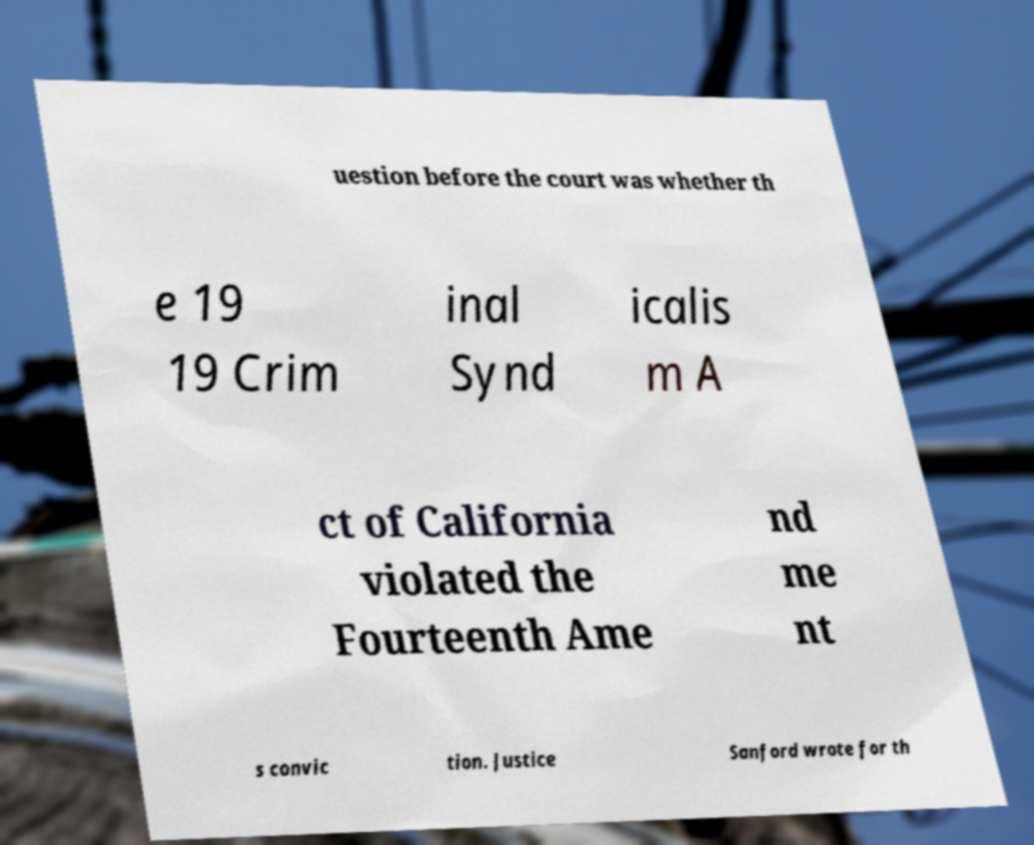Please identify and transcribe the text found in this image. uestion before the court was whether th e 19 19 Crim inal Synd icalis m A ct of California violated the Fourteenth Ame nd me nt s convic tion. Justice Sanford wrote for th 